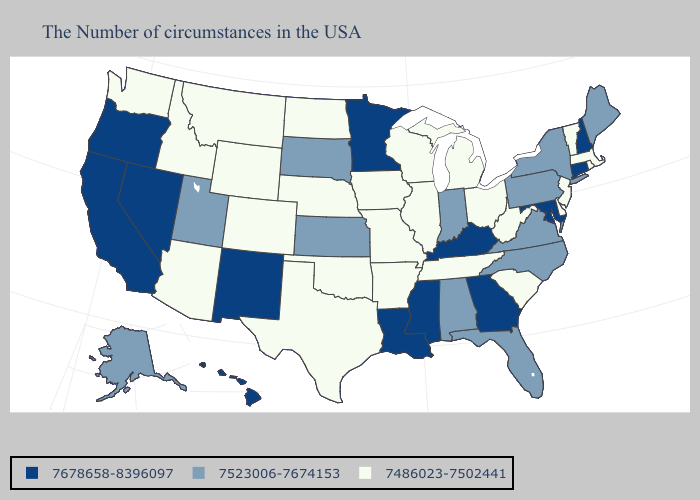Does Nebraska have the lowest value in the MidWest?
Keep it brief. Yes. Name the states that have a value in the range 7523006-7674153?
Answer briefly. Maine, New York, Pennsylvania, Virginia, North Carolina, Florida, Indiana, Alabama, Kansas, South Dakota, Utah, Alaska. Does West Virginia have the lowest value in the USA?
Concise answer only. Yes. Does Alabama have a higher value than Wyoming?
Short answer required. Yes. What is the value of Minnesota?
Give a very brief answer. 7678658-8396097. Name the states that have a value in the range 7523006-7674153?
Answer briefly. Maine, New York, Pennsylvania, Virginia, North Carolina, Florida, Indiana, Alabama, Kansas, South Dakota, Utah, Alaska. What is the value of New Hampshire?
Quick response, please. 7678658-8396097. Does New York have the lowest value in the Northeast?
Give a very brief answer. No. Does Massachusetts have a lower value than Texas?
Short answer required. No. What is the lowest value in the USA?
Answer briefly. 7486023-7502441. How many symbols are there in the legend?
Concise answer only. 3. Name the states that have a value in the range 7523006-7674153?
Write a very short answer. Maine, New York, Pennsylvania, Virginia, North Carolina, Florida, Indiana, Alabama, Kansas, South Dakota, Utah, Alaska. What is the lowest value in the MidWest?
Give a very brief answer. 7486023-7502441. Does Oregon have the lowest value in the USA?
Concise answer only. No. Which states have the lowest value in the Northeast?
Be succinct. Massachusetts, Rhode Island, Vermont, New Jersey. 